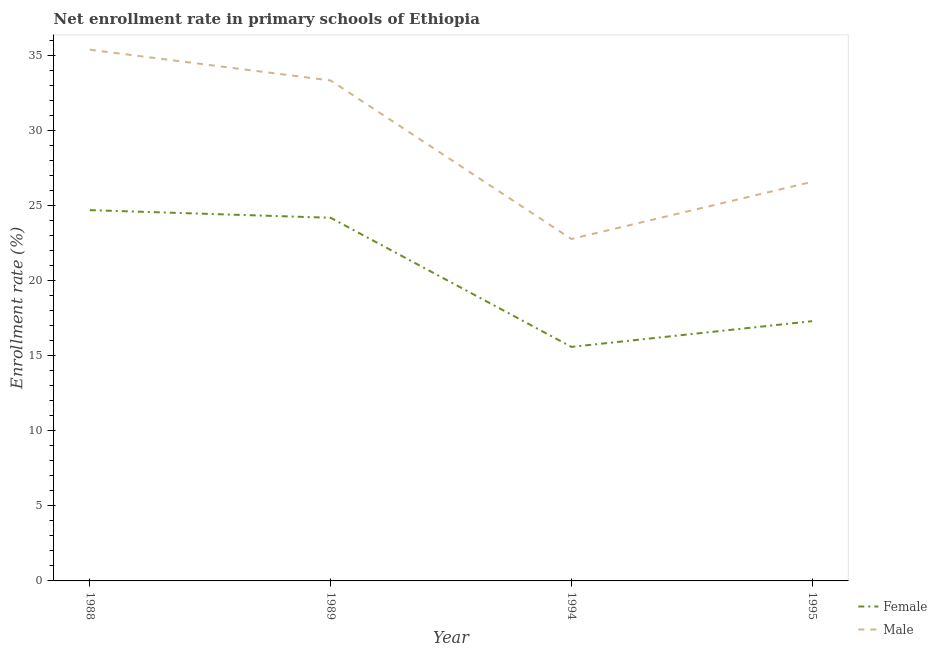Is the number of lines equal to the number of legend labels?
Offer a very short reply. Yes. What is the enrollment rate of female students in 1988?
Provide a short and direct response. 24.69. Across all years, what is the maximum enrollment rate of female students?
Provide a succinct answer. 24.69. Across all years, what is the minimum enrollment rate of female students?
Give a very brief answer. 15.58. In which year was the enrollment rate of female students maximum?
Ensure brevity in your answer.  1988. In which year was the enrollment rate of male students minimum?
Offer a terse response. 1994. What is the total enrollment rate of female students in the graph?
Keep it short and to the point. 81.75. What is the difference between the enrollment rate of male students in 1989 and that in 1994?
Ensure brevity in your answer.  10.55. What is the difference between the enrollment rate of female students in 1994 and the enrollment rate of male students in 1995?
Give a very brief answer. -10.99. What is the average enrollment rate of male students per year?
Ensure brevity in your answer.  29.51. In the year 1989, what is the difference between the enrollment rate of male students and enrollment rate of female students?
Give a very brief answer. 9.14. In how many years, is the enrollment rate of female students greater than 1 %?
Your response must be concise. 4. What is the ratio of the enrollment rate of male students in 1988 to that in 1994?
Provide a short and direct response. 1.55. What is the difference between the highest and the second highest enrollment rate of male students?
Your response must be concise. 2.05. What is the difference between the highest and the lowest enrollment rate of female students?
Offer a very short reply. 9.11. In how many years, is the enrollment rate of female students greater than the average enrollment rate of female students taken over all years?
Your answer should be compact. 2. Is the sum of the enrollment rate of female students in 1994 and 1995 greater than the maximum enrollment rate of male students across all years?
Give a very brief answer. No. How many lines are there?
Your answer should be very brief. 2. Does the graph contain any zero values?
Offer a terse response. No. Does the graph contain grids?
Offer a very short reply. No. Where does the legend appear in the graph?
Keep it short and to the point. Bottom right. How are the legend labels stacked?
Your answer should be compact. Vertical. What is the title of the graph?
Your answer should be very brief. Net enrollment rate in primary schools of Ethiopia. What is the label or title of the Y-axis?
Provide a succinct answer. Enrollment rate (%). What is the Enrollment rate (%) of Female in 1988?
Your answer should be compact. 24.69. What is the Enrollment rate (%) in Male in 1988?
Give a very brief answer. 35.37. What is the Enrollment rate (%) in Female in 1989?
Offer a very short reply. 24.18. What is the Enrollment rate (%) of Male in 1989?
Keep it short and to the point. 33.32. What is the Enrollment rate (%) of Female in 1994?
Offer a terse response. 15.58. What is the Enrollment rate (%) in Male in 1994?
Keep it short and to the point. 22.77. What is the Enrollment rate (%) in Female in 1995?
Ensure brevity in your answer.  17.3. What is the Enrollment rate (%) in Male in 1995?
Provide a short and direct response. 26.58. Across all years, what is the maximum Enrollment rate (%) in Female?
Provide a succinct answer. 24.69. Across all years, what is the maximum Enrollment rate (%) of Male?
Your answer should be very brief. 35.37. Across all years, what is the minimum Enrollment rate (%) in Female?
Keep it short and to the point. 15.58. Across all years, what is the minimum Enrollment rate (%) of Male?
Provide a short and direct response. 22.77. What is the total Enrollment rate (%) of Female in the graph?
Ensure brevity in your answer.  81.75. What is the total Enrollment rate (%) of Male in the graph?
Your answer should be very brief. 118.03. What is the difference between the Enrollment rate (%) of Female in 1988 and that in 1989?
Offer a terse response. 0.51. What is the difference between the Enrollment rate (%) in Male in 1988 and that in 1989?
Provide a short and direct response. 2.05. What is the difference between the Enrollment rate (%) of Female in 1988 and that in 1994?
Ensure brevity in your answer.  9.11. What is the difference between the Enrollment rate (%) in Male in 1988 and that in 1994?
Offer a very short reply. 12.6. What is the difference between the Enrollment rate (%) in Female in 1988 and that in 1995?
Your response must be concise. 7.39. What is the difference between the Enrollment rate (%) of Male in 1988 and that in 1995?
Provide a succinct answer. 8.79. What is the difference between the Enrollment rate (%) of Female in 1989 and that in 1994?
Your answer should be very brief. 8.6. What is the difference between the Enrollment rate (%) of Male in 1989 and that in 1994?
Offer a very short reply. 10.55. What is the difference between the Enrollment rate (%) in Female in 1989 and that in 1995?
Give a very brief answer. 6.88. What is the difference between the Enrollment rate (%) in Male in 1989 and that in 1995?
Give a very brief answer. 6.75. What is the difference between the Enrollment rate (%) in Female in 1994 and that in 1995?
Your response must be concise. -1.71. What is the difference between the Enrollment rate (%) in Male in 1994 and that in 1995?
Give a very brief answer. -3.81. What is the difference between the Enrollment rate (%) of Female in 1988 and the Enrollment rate (%) of Male in 1989?
Your response must be concise. -8.63. What is the difference between the Enrollment rate (%) of Female in 1988 and the Enrollment rate (%) of Male in 1994?
Give a very brief answer. 1.92. What is the difference between the Enrollment rate (%) in Female in 1988 and the Enrollment rate (%) in Male in 1995?
Offer a very short reply. -1.89. What is the difference between the Enrollment rate (%) in Female in 1989 and the Enrollment rate (%) in Male in 1994?
Provide a succinct answer. 1.41. What is the difference between the Enrollment rate (%) in Female in 1989 and the Enrollment rate (%) in Male in 1995?
Offer a very short reply. -2.4. What is the difference between the Enrollment rate (%) of Female in 1994 and the Enrollment rate (%) of Male in 1995?
Ensure brevity in your answer.  -10.99. What is the average Enrollment rate (%) of Female per year?
Your answer should be compact. 20.44. What is the average Enrollment rate (%) of Male per year?
Make the answer very short. 29.51. In the year 1988, what is the difference between the Enrollment rate (%) of Female and Enrollment rate (%) of Male?
Give a very brief answer. -10.68. In the year 1989, what is the difference between the Enrollment rate (%) of Female and Enrollment rate (%) of Male?
Provide a succinct answer. -9.14. In the year 1994, what is the difference between the Enrollment rate (%) of Female and Enrollment rate (%) of Male?
Give a very brief answer. -7.18. In the year 1995, what is the difference between the Enrollment rate (%) of Female and Enrollment rate (%) of Male?
Make the answer very short. -9.28. What is the ratio of the Enrollment rate (%) in Female in 1988 to that in 1989?
Make the answer very short. 1.02. What is the ratio of the Enrollment rate (%) in Male in 1988 to that in 1989?
Provide a short and direct response. 1.06. What is the ratio of the Enrollment rate (%) in Female in 1988 to that in 1994?
Keep it short and to the point. 1.58. What is the ratio of the Enrollment rate (%) of Male in 1988 to that in 1994?
Make the answer very short. 1.55. What is the ratio of the Enrollment rate (%) of Female in 1988 to that in 1995?
Offer a terse response. 1.43. What is the ratio of the Enrollment rate (%) of Male in 1988 to that in 1995?
Your answer should be very brief. 1.33. What is the ratio of the Enrollment rate (%) of Female in 1989 to that in 1994?
Make the answer very short. 1.55. What is the ratio of the Enrollment rate (%) in Male in 1989 to that in 1994?
Give a very brief answer. 1.46. What is the ratio of the Enrollment rate (%) of Female in 1989 to that in 1995?
Offer a terse response. 1.4. What is the ratio of the Enrollment rate (%) in Male in 1989 to that in 1995?
Your answer should be very brief. 1.25. What is the ratio of the Enrollment rate (%) of Female in 1994 to that in 1995?
Your answer should be compact. 0.9. What is the ratio of the Enrollment rate (%) of Male in 1994 to that in 1995?
Give a very brief answer. 0.86. What is the difference between the highest and the second highest Enrollment rate (%) of Female?
Offer a terse response. 0.51. What is the difference between the highest and the second highest Enrollment rate (%) in Male?
Make the answer very short. 2.05. What is the difference between the highest and the lowest Enrollment rate (%) of Female?
Make the answer very short. 9.11. What is the difference between the highest and the lowest Enrollment rate (%) of Male?
Ensure brevity in your answer.  12.6. 